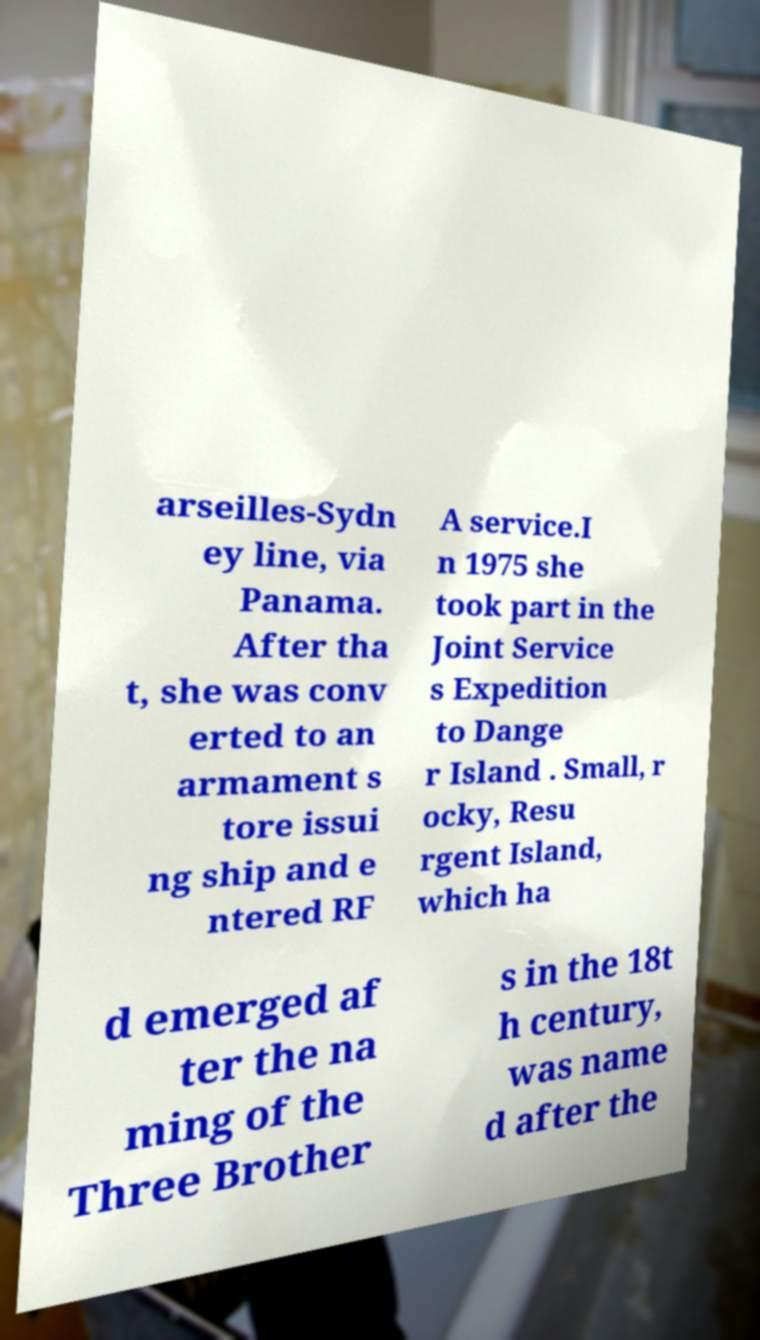Can you read and provide the text displayed in the image?This photo seems to have some interesting text. Can you extract and type it out for me? arseilles-Sydn ey line, via Panama. After tha t, she was conv erted to an armament s tore issui ng ship and e ntered RF A service.I n 1975 she took part in the Joint Service s Expedition to Dange r Island . Small, r ocky, Resu rgent Island, which ha d emerged af ter the na ming of the Three Brother s in the 18t h century, was name d after the 